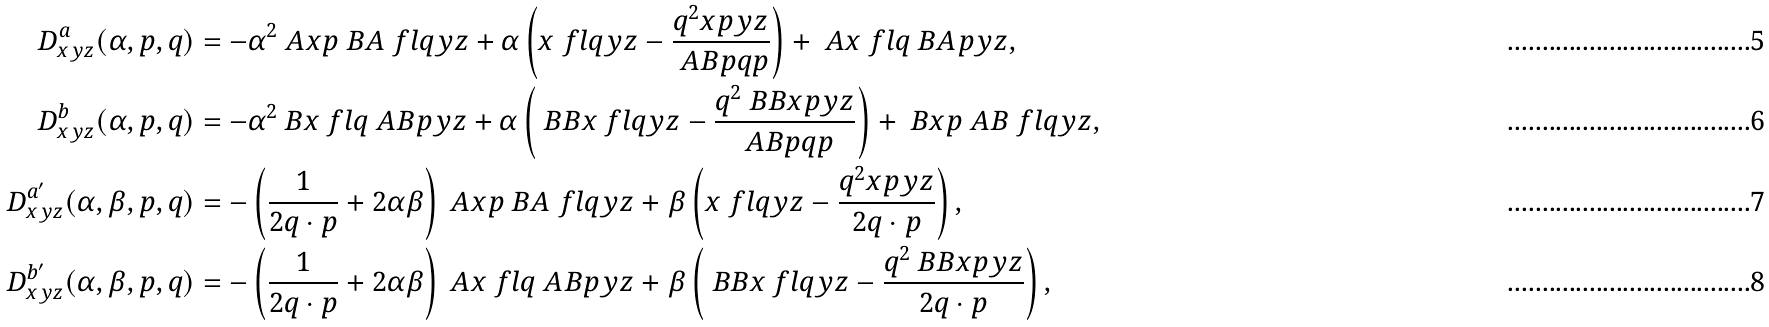Convert formula to latex. <formula><loc_0><loc_0><loc_500><loc_500>D ^ { a } _ { x y z } ( \alpha , p , q ) & = - \alpha ^ { 2 } \ A { x } { p } \ B A { \ f l q } { y } { z } + \alpha \left ( \AA x { \ f l q y } z - \frac { q ^ { 2 } \AA x { p y } z } { \ A B p q p } \right ) + \ A { x } { \ f l q } \ B A { p } { y } { z } , \\ D ^ { b } _ { x y z } ( \alpha , p , q ) & = - \alpha ^ { 2 } \ B { x } { \ f l q } \ A B { p } { y } { z } + \alpha \left ( \ B B x { \ f l q y } z - \frac { q ^ { 2 } \ B B x { p y } z } { \ A B p q p } \right ) + \ B { x } { p } \ A B { \ f l q } { y } { z } , \\ D ^ { a ^ { \prime } } _ { x y z } ( \alpha , \beta , p , q ) & = - \left ( \frac { 1 } { 2 q \cdot p } + 2 \alpha \beta \right ) \ A x p \ B A { \ f l q } { y } { z } + \beta \left ( \AA { x } { \ f l q y } { z } - \frac { q ^ { 2 } \AA { x } { p y } { z } } { 2 q \cdot p } \right ) , \\ D ^ { b ^ { \prime } } _ { x y z } ( \alpha , \beta , p , q ) & = - \left ( \frac { 1 } { 2 q \cdot p } + 2 \alpha \beta \right ) \ A x { \ f l q } \ A B p { y } { z } + \beta \left ( \ B B { x } { \ f l q y } { z } - \frac { q ^ { 2 } \ B B { x } { p y } { z } } { 2 q \cdot p } \right ) ,</formula> 